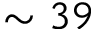Convert formula to latex. <formula><loc_0><loc_0><loc_500><loc_500>\sim 3 9</formula> 